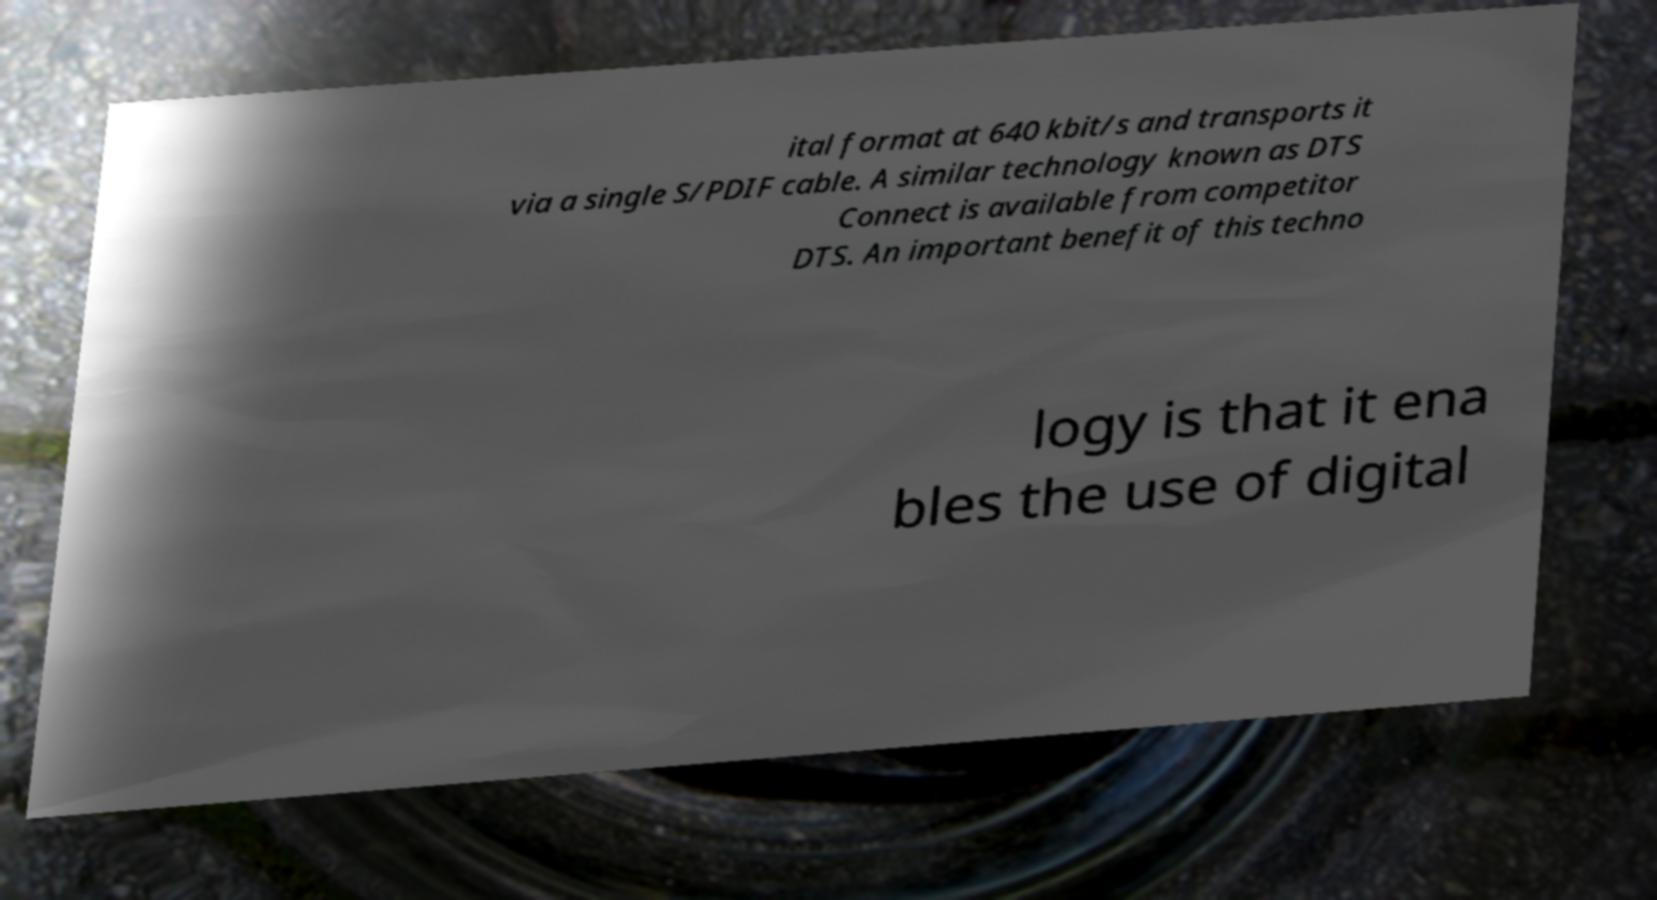Can you read and provide the text displayed in the image?This photo seems to have some interesting text. Can you extract and type it out for me? ital format at 640 kbit/s and transports it via a single S/PDIF cable. A similar technology known as DTS Connect is available from competitor DTS. An important benefit of this techno logy is that it ena bles the use of digital 